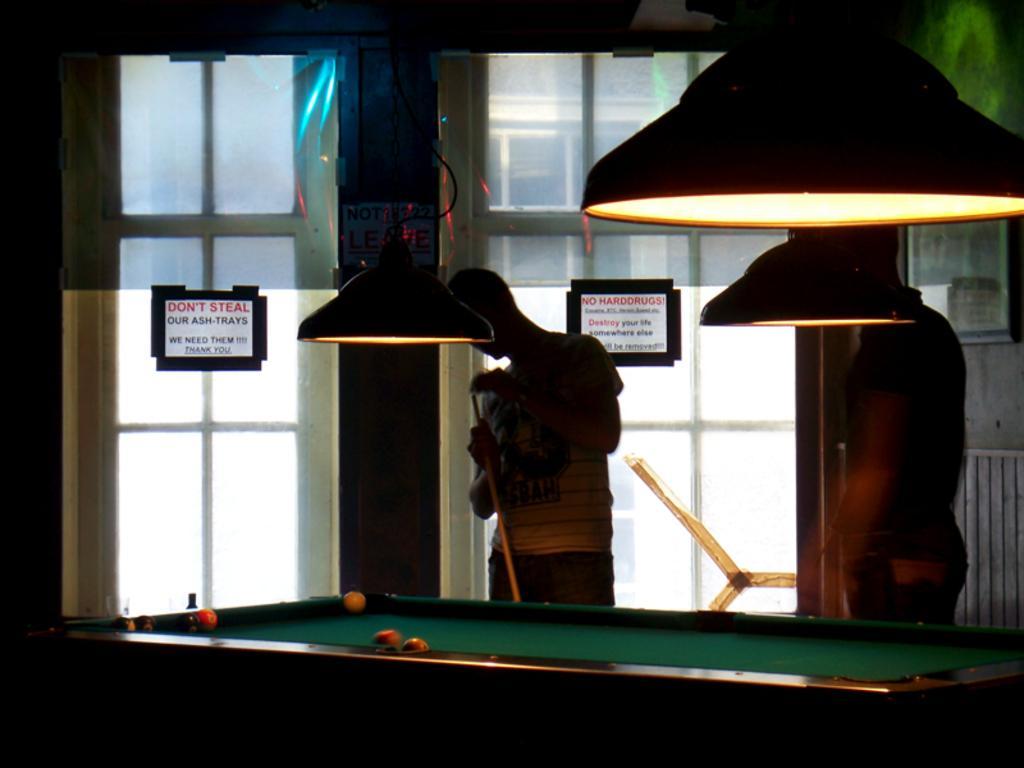Please provide a concise description of this image. In this picture we can see two men standing in front of a snooker table and here we can see two paper notes which are sticked over the window. 